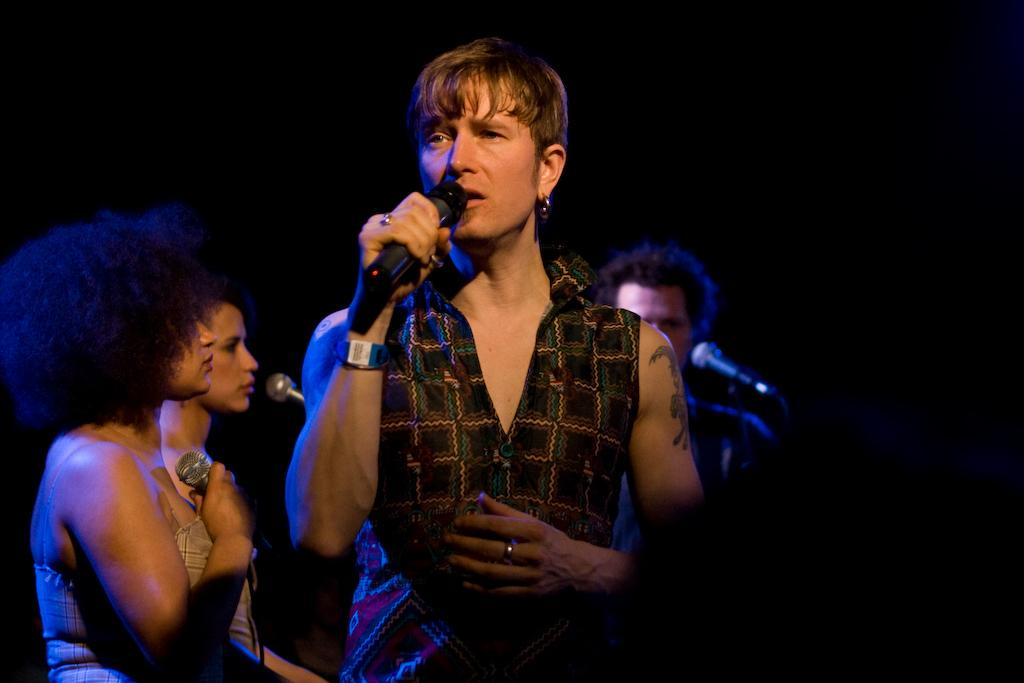How many people are in the image? There are four persons in the image. What are two of the persons doing in the image? Two of the persons are holding microphones. How many girls are present in the image? The provided facts do not mention the gender of the persons in the image, so it is impossible to determine the number of girls present. 